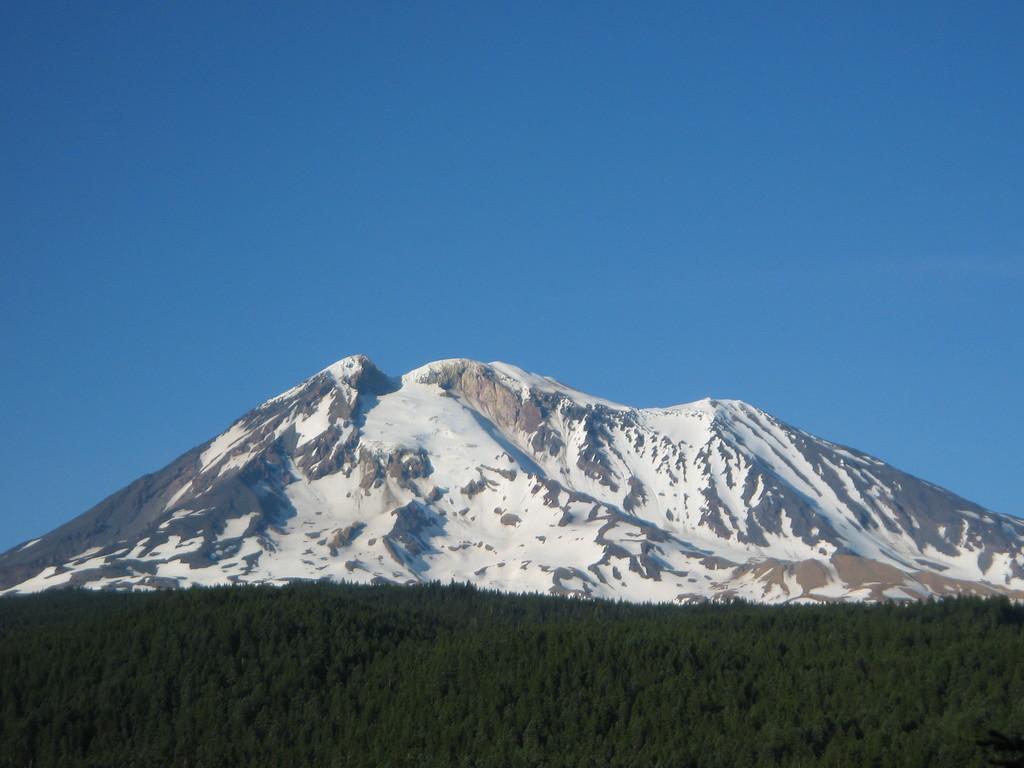In one or two sentences, can you explain what this image depicts? in this image there are some trees in the background and there is a mountain in middle of this image and there is a blue sky at top of this image. 